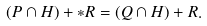Convert formula to latex. <formula><loc_0><loc_0><loc_500><loc_500>( P \cap H ) + * R = ( Q \cap H ) + R .</formula> 